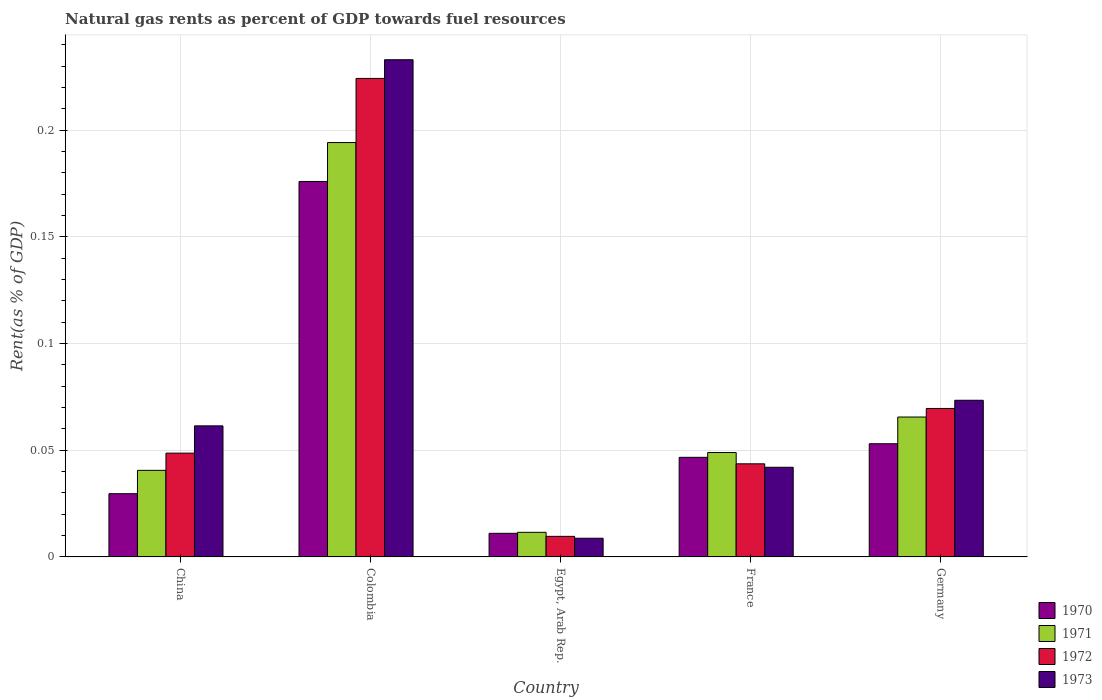How many different coloured bars are there?
Your response must be concise. 4. Are the number of bars per tick equal to the number of legend labels?
Keep it short and to the point. Yes. How many bars are there on the 5th tick from the left?
Your answer should be compact. 4. How many bars are there on the 4th tick from the right?
Provide a short and direct response. 4. What is the label of the 5th group of bars from the left?
Offer a terse response. Germany. In how many cases, is the number of bars for a given country not equal to the number of legend labels?
Offer a terse response. 0. What is the matural gas rent in 1972 in China?
Offer a terse response. 0.05. Across all countries, what is the maximum matural gas rent in 1972?
Give a very brief answer. 0.22. Across all countries, what is the minimum matural gas rent in 1970?
Give a very brief answer. 0.01. In which country was the matural gas rent in 1971 minimum?
Keep it short and to the point. Egypt, Arab Rep. What is the total matural gas rent in 1971 in the graph?
Make the answer very short. 0.36. What is the difference between the matural gas rent in 1972 in China and that in France?
Offer a very short reply. 0.01. What is the difference between the matural gas rent in 1970 in Germany and the matural gas rent in 1971 in Egypt, Arab Rep.?
Your answer should be very brief. 0.04. What is the average matural gas rent in 1972 per country?
Your answer should be compact. 0.08. What is the difference between the matural gas rent of/in 1972 and matural gas rent of/in 1971 in France?
Offer a terse response. -0.01. What is the ratio of the matural gas rent in 1970 in China to that in Egypt, Arab Rep.?
Ensure brevity in your answer.  2.68. Is the matural gas rent in 1972 in Colombia less than that in France?
Your answer should be compact. No. What is the difference between the highest and the second highest matural gas rent in 1971?
Provide a succinct answer. 0.13. What is the difference between the highest and the lowest matural gas rent in 1973?
Offer a terse response. 0.22. Is the sum of the matural gas rent in 1973 in Colombia and Egypt, Arab Rep. greater than the maximum matural gas rent in 1970 across all countries?
Your response must be concise. Yes. Is it the case that in every country, the sum of the matural gas rent in 1971 and matural gas rent in 1973 is greater than the sum of matural gas rent in 1970 and matural gas rent in 1972?
Your answer should be compact. No. What does the 2nd bar from the left in China represents?
Offer a terse response. 1971. What does the 2nd bar from the right in Egypt, Arab Rep. represents?
Make the answer very short. 1972. Is it the case that in every country, the sum of the matural gas rent in 1973 and matural gas rent in 1970 is greater than the matural gas rent in 1972?
Make the answer very short. Yes. How many bars are there?
Your answer should be compact. 20. Are all the bars in the graph horizontal?
Keep it short and to the point. No. How many countries are there in the graph?
Offer a terse response. 5. Does the graph contain any zero values?
Provide a short and direct response. No. Does the graph contain grids?
Offer a terse response. Yes. What is the title of the graph?
Keep it short and to the point. Natural gas rents as percent of GDP towards fuel resources. Does "1981" appear as one of the legend labels in the graph?
Your answer should be very brief. No. What is the label or title of the X-axis?
Offer a very short reply. Country. What is the label or title of the Y-axis?
Your answer should be very brief. Rent(as % of GDP). What is the Rent(as % of GDP) of 1970 in China?
Offer a very short reply. 0.03. What is the Rent(as % of GDP) of 1971 in China?
Provide a succinct answer. 0.04. What is the Rent(as % of GDP) of 1972 in China?
Provide a succinct answer. 0.05. What is the Rent(as % of GDP) of 1973 in China?
Your answer should be compact. 0.06. What is the Rent(as % of GDP) of 1970 in Colombia?
Keep it short and to the point. 0.18. What is the Rent(as % of GDP) of 1971 in Colombia?
Make the answer very short. 0.19. What is the Rent(as % of GDP) of 1972 in Colombia?
Your response must be concise. 0.22. What is the Rent(as % of GDP) of 1973 in Colombia?
Ensure brevity in your answer.  0.23. What is the Rent(as % of GDP) of 1970 in Egypt, Arab Rep.?
Provide a short and direct response. 0.01. What is the Rent(as % of GDP) of 1971 in Egypt, Arab Rep.?
Your answer should be very brief. 0.01. What is the Rent(as % of GDP) of 1972 in Egypt, Arab Rep.?
Provide a succinct answer. 0.01. What is the Rent(as % of GDP) in 1973 in Egypt, Arab Rep.?
Ensure brevity in your answer.  0.01. What is the Rent(as % of GDP) of 1970 in France?
Make the answer very short. 0.05. What is the Rent(as % of GDP) in 1971 in France?
Your answer should be compact. 0.05. What is the Rent(as % of GDP) of 1972 in France?
Keep it short and to the point. 0.04. What is the Rent(as % of GDP) in 1973 in France?
Keep it short and to the point. 0.04. What is the Rent(as % of GDP) of 1970 in Germany?
Provide a succinct answer. 0.05. What is the Rent(as % of GDP) in 1971 in Germany?
Your answer should be very brief. 0.07. What is the Rent(as % of GDP) of 1972 in Germany?
Offer a terse response. 0.07. What is the Rent(as % of GDP) in 1973 in Germany?
Provide a short and direct response. 0.07. Across all countries, what is the maximum Rent(as % of GDP) in 1970?
Offer a very short reply. 0.18. Across all countries, what is the maximum Rent(as % of GDP) of 1971?
Keep it short and to the point. 0.19. Across all countries, what is the maximum Rent(as % of GDP) of 1972?
Your answer should be compact. 0.22. Across all countries, what is the maximum Rent(as % of GDP) of 1973?
Ensure brevity in your answer.  0.23. Across all countries, what is the minimum Rent(as % of GDP) in 1970?
Provide a succinct answer. 0.01. Across all countries, what is the minimum Rent(as % of GDP) in 1971?
Provide a short and direct response. 0.01. Across all countries, what is the minimum Rent(as % of GDP) of 1972?
Offer a terse response. 0.01. Across all countries, what is the minimum Rent(as % of GDP) in 1973?
Your answer should be very brief. 0.01. What is the total Rent(as % of GDP) in 1970 in the graph?
Ensure brevity in your answer.  0.32. What is the total Rent(as % of GDP) of 1971 in the graph?
Keep it short and to the point. 0.36. What is the total Rent(as % of GDP) in 1972 in the graph?
Make the answer very short. 0.4. What is the total Rent(as % of GDP) in 1973 in the graph?
Your response must be concise. 0.42. What is the difference between the Rent(as % of GDP) in 1970 in China and that in Colombia?
Keep it short and to the point. -0.15. What is the difference between the Rent(as % of GDP) in 1971 in China and that in Colombia?
Your answer should be compact. -0.15. What is the difference between the Rent(as % of GDP) in 1972 in China and that in Colombia?
Your answer should be very brief. -0.18. What is the difference between the Rent(as % of GDP) in 1973 in China and that in Colombia?
Give a very brief answer. -0.17. What is the difference between the Rent(as % of GDP) in 1970 in China and that in Egypt, Arab Rep.?
Your response must be concise. 0.02. What is the difference between the Rent(as % of GDP) in 1971 in China and that in Egypt, Arab Rep.?
Ensure brevity in your answer.  0.03. What is the difference between the Rent(as % of GDP) in 1972 in China and that in Egypt, Arab Rep.?
Your response must be concise. 0.04. What is the difference between the Rent(as % of GDP) in 1973 in China and that in Egypt, Arab Rep.?
Provide a succinct answer. 0.05. What is the difference between the Rent(as % of GDP) in 1970 in China and that in France?
Ensure brevity in your answer.  -0.02. What is the difference between the Rent(as % of GDP) of 1971 in China and that in France?
Offer a terse response. -0.01. What is the difference between the Rent(as % of GDP) in 1972 in China and that in France?
Ensure brevity in your answer.  0.01. What is the difference between the Rent(as % of GDP) in 1973 in China and that in France?
Offer a terse response. 0.02. What is the difference between the Rent(as % of GDP) of 1970 in China and that in Germany?
Make the answer very short. -0.02. What is the difference between the Rent(as % of GDP) of 1971 in China and that in Germany?
Provide a short and direct response. -0.03. What is the difference between the Rent(as % of GDP) in 1972 in China and that in Germany?
Make the answer very short. -0.02. What is the difference between the Rent(as % of GDP) of 1973 in China and that in Germany?
Offer a very short reply. -0.01. What is the difference between the Rent(as % of GDP) in 1970 in Colombia and that in Egypt, Arab Rep.?
Ensure brevity in your answer.  0.16. What is the difference between the Rent(as % of GDP) in 1971 in Colombia and that in Egypt, Arab Rep.?
Provide a succinct answer. 0.18. What is the difference between the Rent(as % of GDP) of 1972 in Colombia and that in Egypt, Arab Rep.?
Ensure brevity in your answer.  0.21. What is the difference between the Rent(as % of GDP) of 1973 in Colombia and that in Egypt, Arab Rep.?
Keep it short and to the point. 0.22. What is the difference between the Rent(as % of GDP) in 1970 in Colombia and that in France?
Your response must be concise. 0.13. What is the difference between the Rent(as % of GDP) in 1971 in Colombia and that in France?
Provide a short and direct response. 0.15. What is the difference between the Rent(as % of GDP) in 1972 in Colombia and that in France?
Your response must be concise. 0.18. What is the difference between the Rent(as % of GDP) of 1973 in Colombia and that in France?
Provide a short and direct response. 0.19. What is the difference between the Rent(as % of GDP) of 1970 in Colombia and that in Germany?
Make the answer very short. 0.12. What is the difference between the Rent(as % of GDP) in 1971 in Colombia and that in Germany?
Make the answer very short. 0.13. What is the difference between the Rent(as % of GDP) of 1972 in Colombia and that in Germany?
Offer a very short reply. 0.15. What is the difference between the Rent(as % of GDP) in 1973 in Colombia and that in Germany?
Ensure brevity in your answer.  0.16. What is the difference between the Rent(as % of GDP) of 1970 in Egypt, Arab Rep. and that in France?
Provide a short and direct response. -0.04. What is the difference between the Rent(as % of GDP) in 1971 in Egypt, Arab Rep. and that in France?
Your answer should be compact. -0.04. What is the difference between the Rent(as % of GDP) in 1972 in Egypt, Arab Rep. and that in France?
Your response must be concise. -0.03. What is the difference between the Rent(as % of GDP) of 1973 in Egypt, Arab Rep. and that in France?
Your answer should be compact. -0.03. What is the difference between the Rent(as % of GDP) of 1970 in Egypt, Arab Rep. and that in Germany?
Provide a succinct answer. -0.04. What is the difference between the Rent(as % of GDP) of 1971 in Egypt, Arab Rep. and that in Germany?
Offer a terse response. -0.05. What is the difference between the Rent(as % of GDP) in 1972 in Egypt, Arab Rep. and that in Germany?
Ensure brevity in your answer.  -0.06. What is the difference between the Rent(as % of GDP) in 1973 in Egypt, Arab Rep. and that in Germany?
Provide a succinct answer. -0.06. What is the difference between the Rent(as % of GDP) of 1970 in France and that in Germany?
Offer a terse response. -0.01. What is the difference between the Rent(as % of GDP) in 1971 in France and that in Germany?
Provide a succinct answer. -0.02. What is the difference between the Rent(as % of GDP) of 1972 in France and that in Germany?
Your answer should be compact. -0.03. What is the difference between the Rent(as % of GDP) in 1973 in France and that in Germany?
Provide a succinct answer. -0.03. What is the difference between the Rent(as % of GDP) in 1970 in China and the Rent(as % of GDP) in 1971 in Colombia?
Your answer should be compact. -0.16. What is the difference between the Rent(as % of GDP) of 1970 in China and the Rent(as % of GDP) of 1972 in Colombia?
Your answer should be compact. -0.19. What is the difference between the Rent(as % of GDP) of 1970 in China and the Rent(as % of GDP) of 1973 in Colombia?
Your answer should be very brief. -0.2. What is the difference between the Rent(as % of GDP) of 1971 in China and the Rent(as % of GDP) of 1972 in Colombia?
Ensure brevity in your answer.  -0.18. What is the difference between the Rent(as % of GDP) of 1971 in China and the Rent(as % of GDP) of 1973 in Colombia?
Keep it short and to the point. -0.19. What is the difference between the Rent(as % of GDP) of 1972 in China and the Rent(as % of GDP) of 1973 in Colombia?
Ensure brevity in your answer.  -0.18. What is the difference between the Rent(as % of GDP) in 1970 in China and the Rent(as % of GDP) in 1971 in Egypt, Arab Rep.?
Your answer should be very brief. 0.02. What is the difference between the Rent(as % of GDP) in 1970 in China and the Rent(as % of GDP) in 1973 in Egypt, Arab Rep.?
Make the answer very short. 0.02. What is the difference between the Rent(as % of GDP) of 1971 in China and the Rent(as % of GDP) of 1972 in Egypt, Arab Rep.?
Offer a very short reply. 0.03. What is the difference between the Rent(as % of GDP) in 1971 in China and the Rent(as % of GDP) in 1973 in Egypt, Arab Rep.?
Provide a succinct answer. 0.03. What is the difference between the Rent(as % of GDP) in 1972 in China and the Rent(as % of GDP) in 1973 in Egypt, Arab Rep.?
Ensure brevity in your answer.  0.04. What is the difference between the Rent(as % of GDP) in 1970 in China and the Rent(as % of GDP) in 1971 in France?
Your answer should be very brief. -0.02. What is the difference between the Rent(as % of GDP) in 1970 in China and the Rent(as % of GDP) in 1972 in France?
Offer a very short reply. -0.01. What is the difference between the Rent(as % of GDP) of 1970 in China and the Rent(as % of GDP) of 1973 in France?
Your answer should be very brief. -0.01. What is the difference between the Rent(as % of GDP) of 1971 in China and the Rent(as % of GDP) of 1972 in France?
Your answer should be very brief. -0. What is the difference between the Rent(as % of GDP) of 1971 in China and the Rent(as % of GDP) of 1973 in France?
Provide a succinct answer. -0. What is the difference between the Rent(as % of GDP) of 1972 in China and the Rent(as % of GDP) of 1973 in France?
Provide a succinct answer. 0.01. What is the difference between the Rent(as % of GDP) of 1970 in China and the Rent(as % of GDP) of 1971 in Germany?
Provide a succinct answer. -0.04. What is the difference between the Rent(as % of GDP) in 1970 in China and the Rent(as % of GDP) in 1972 in Germany?
Make the answer very short. -0.04. What is the difference between the Rent(as % of GDP) of 1970 in China and the Rent(as % of GDP) of 1973 in Germany?
Your response must be concise. -0.04. What is the difference between the Rent(as % of GDP) in 1971 in China and the Rent(as % of GDP) in 1972 in Germany?
Your answer should be very brief. -0.03. What is the difference between the Rent(as % of GDP) in 1971 in China and the Rent(as % of GDP) in 1973 in Germany?
Make the answer very short. -0.03. What is the difference between the Rent(as % of GDP) in 1972 in China and the Rent(as % of GDP) in 1973 in Germany?
Make the answer very short. -0.02. What is the difference between the Rent(as % of GDP) of 1970 in Colombia and the Rent(as % of GDP) of 1971 in Egypt, Arab Rep.?
Provide a short and direct response. 0.16. What is the difference between the Rent(as % of GDP) in 1970 in Colombia and the Rent(as % of GDP) in 1972 in Egypt, Arab Rep.?
Your answer should be very brief. 0.17. What is the difference between the Rent(as % of GDP) in 1970 in Colombia and the Rent(as % of GDP) in 1973 in Egypt, Arab Rep.?
Provide a succinct answer. 0.17. What is the difference between the Rent(as % of GDP) in 1971 in Colombia and the Rent(as % of GDP) in 1972 in Egypt, Arab Rep.?
Provide a short and direct response. 0.18. What is the difference between the Rent(as % of GDP) of 1971 in Colombia and the Rent(as % of GDP) of 1973 in Egypt, Arab Rep.?
Your answer should be very brief. 0.19. What is the difference between the Rent(as % of GDP) in 1972 in Colombia and the Rent(as % of GDP) in 1973 in Egypt, Arab Rep.?
Your answer should be compact. 0.22. What is the difference between the Rent(as % of GDP) in 1970 in Colombia and the Rent(as % of GDP) in 1971 in France?
Your response must be concise. 0.13. What is the difference between the Rent(as % of GDP) of 1970 in Colombia and the Rent(as % of GDP) of 1972 in France?
Offer a very short reply. 0.13. What is the difference between the Rent(as % of GDP) of 1970 in Colombia and the Rent(as % of GDP) of 1973 in France?
Offer a terse response. 0.13. What is the difference between the Rent(as % of GDP) in 1971 in Colombia and the Rent(as % of GDP) in 1972 in France?
Your answer should be very brief. 0.15. What is the difference between the Rent(as % of GDP) of 1971 in Colombia and the Rent(as % of GDP) of 1973 in France?
Your answer should be very brief. 0.15. What is the difference between the Rent(as % of GDP) in 1972 in Colombia and the Rent(as % of GDP) in 1973 in France?
Your answer should be compact. 0.18. What is the difference between the Rent(as % of GDP) in 1970 in Colombia and the Rent(as % of GDP) in 1971 in Germany?
Provide a succinct answer. 0.11. What is the difference between the Rent(as % of GDP) in 1970 in Colombia and the Rent(as % of GDP) in 1972 in Germany?
Offer a very short reply. 0.11. What is the difference between the Rent(as % of GDP) of 1970 in Colombia and the Rent(as % of GDP) of 1973 in Germany?
Provide a short and direct response. 0.1. What is the difference between the Rent(as % of GDP) of 1971 in Colombia and the Rent(as % of GDP) of 1972 in Germany?
Your response must be concise. 0.12. What is the difference between the Rent(as % of GDP) of 1971 in Colombia and the Rent(as % of GDP) of 1973 in Germany?
Your response must be concise. 0.12. What is the difference between the Rent(as % of GDP) of 1972 in Colombia and the Rent(as % of GDP) of 1973 in Germany?
Offer a very short reply. 0.15. What is the difference between the Rent(as % of GDP) in 1970 in Egypt, Arab Rep. and the Rent(as % of GDP) in 1971 in France?
Ensure brevity in your answer.  -0.04. What is the difference between the Rent(as % of GDP) of 1970 in Egypt, Arab Rep. and the Rent(as % of GDP) of 1972 in France?
Give a very brief answer. -0.03. What is the difference between the Rent(as % of GDP) of 1970 in Egypt, Arab Rep. and the Rent(as % of GDP) of 1973 in France?
Your response must be concise. -0.03. What is the difference between the Rent(as % of GDP) of 1971 in Egypt, Arab Rep. and the Rent(as % of GDP) of 1972 in France?
Ensure brevity in your answer.  -0.03. What is the difference between the Rent(as % of GDP) of 1971 in Egypt, Arab Rep. and the Rent(as % of GDP) of 1973 in France?
Give a very brief answer. -0.03. What is the difference between the Rent(as % of GDP) of 1972 in Egypt, Arab Rep. and the Rent(as % of GDP) of 1973 in France?
Make the answer very short. -0.03. What is the difference between the Rent(as % of GDP) in 1970 in Egypt, Arab Rep. and the Rent(as % of GDP) in 1971 in Germany?
Offer a terse response. -0.05. What is the difference between the Rent(as % of GDP) in 1970 in Egypt, Arab Rep. and the Rent(as % of GDP) in 1972 in Germany?
Offer a very short reply. -0.06. What is the difference between the Rent(as % of GDP) of 1970 in Egypt, Arab Rep. and the Rent(as % of GDP) of 1973 in Germany?
Provide a succinct answer. -0.06. What is the difference between the Rent(as % of GDP) in 1971 in Egypt, Arab Rep. and the Rent(as % of GDP) in 1972 in Germany?
Give a very brief answer. -0.06. What is the difference between the Rent(as % of GDP) of 1971 in Egypt, Arab Rep. and the Rent(as % of GDP) of 1973 in Germany?
Give a very brief answer. -0.06. What is the difference between the Rent(as % of GDP) in 1972 in Egypt, Arab Rep. and the Rent(as % of GDP) in 1973 in Germany?
Give a very brief answer. -0.06. What is the difference between the Rent(as % of GDP) in 1970 in France and the Rent(as % of GDP) in 1971 in Germany?
Your answer should be very brief. -0.02. What is the difference between the Rent(as % of GDP) in 1970 in France and the Rent(as % of GDP) in 1972 in Germany?
Offer a terse response. -0.02. What is the difference between the Rent(as % of GDP) of 1970 in France and the Rent(as % of GDP) of 1973 in Germany?
Provide a succinct answer. -0.03. What is the difference between the Rent(as % of GDP) of 1971 in France and the Rent(as % of GDP) of 1972 in Germany?
Your response must be concise. -0.02. What is the difference between the Rent(as % of GDP) in 1971 in France and the Rent(as % of GDP) in 1973 in Germany?
Your response must be concise. -0.02. What is the difference between the Rent(as % of GDP) in 1972 in France and the Rent(as % of GDP) in 1973 in Germany?
Ensure brevity in your answer.  -0.03. What is the average Rent(as % of GDP) in 1970 per country?
Give a very brief answer. 0.06. What is the average Rent(as % of GDP) in 1971 per country?
Give a very brief answer. 0.07. What is the average Rent(as % of GDP) of 1972 per country?
Your response must be concise. 0.08. What is the average Rent(as % of GDP) in 1973 per country?
Provide a short and direct response. 0.08. What is the difference between the Rent(as % of GDP) of 1970 and Rent(as % of GDP) of 1971 in China?
Keep it short and to the point. -0.01. What is the difference between the Rent(as % of GDP) in 1970 and Rent(as % of GDP) in 1972 in China?
Your response must be concise. -0.02. What is the difference between the Rent(as % of GDP) in 1970 and Rent(as % of GDP) in 1973 in China?
Offer a terse response. -0.03. What is the difference between the Rent(as % of GDP) in 1971 and Rent(as % of GDP) in 1972 in China?
Your answer should be very brief. -0.01. What is the difference between the Rent(as % of GDP) of 1971 and Rent(as % of GDP) of 1973 in China?
Keep it short and to the point. -0.02. What is the difference between the Rent(as % of GDP) of 1972 and Rent(as % of GDP) of 1973 in China?
Your answer should be compact. -0.01. What is the difference between the Rent(as % of GDP) in 1970 and Rent(as % of GDP) in 1971 in Colombia?
Offer a terse response. -0.02. What is the difference between the Rent(as % of GDP) in 1970 and Rent(as % of GDP) in 1972 in Colombia?
Make the answer very short. -0.05. What is the difference between the Rent(as % of GDP) in 1970 and Rent(as % of GDP) in 1973 in Colombia?
Offer a very short reply. -0.06. What is the difference between the Rent(as % of GDP) of 1971 and Rent(as % of GDP) of 1972 in Colombia?
Your answer should be very brief. -0.03. What is the difference between the Rent(as % of GDP) in 1971 and Rent(as % of GDP) in 1973 in Colombia?
Ensure brevity in your answer.  -0.04. What is the difference between the Rent(as % of GDP) in 1972 and Rent(as % of GDP) in 1973 in Colombia?
Give a very brief answer. -0.01. What is the difference between the Rent(as % of GDP) of 1970 and Rent(as % of GDP) of 1971 in Egypt, Arab Rep.?
Provide a succinct answer. -0. What is the difference between the Rent(as % of GDP) of 1970 and Rent(as % of GDP) of 1972 in Egypt, Arab Rep.?
Give a very brief answer. 0. What is the difference between the Rent(as % of GDP) in 1970 and Rent(as % of GDP) in 1973 in Egypt, Arab Rep.?
Keep it short and to the point. 0. What is the difference between the Rent(as % of GDP) of 1971 and Rent(as % of GDP) of 1972 in Egypt, Arab Rep.?
Provide a succinct answer. 0. What is the difference between the Rent(as % of GDP) in 1971 and Rent(as % of GDP) in 1973 in Egypt, Arab Rep.?
Provide a short and direct response. 0. What is the difference between the Rent(as % of GDP) in 1972 and Rent(as % of GDP) in 1973 in Egypt, Arab Rep.?
Your answer should be compact. 0. What is the difference between the Rent(as % of GDP) in 1970 and Rent(as % of GDP) in 1971 in France?
Your answer should be very brief. -0. What is the difference between the Rent(as % of GDP) in 1970 and Rent(as % of GDP) in 1972 in France?
Make the answer very short. 0. What is the difference between the Rent(as % of GDP) in 1970 and Rent(as % of GDP) in 1973 in France?
Your response must be concise. 0. What is the difference between the Rent(as % of GDP) of 1971 and Rent(as % of GDP) of 1972 in France?
Keep it short and to the point. 0.01. What is the difference between the Rent(as % of GDP) in 1971 and Rent(as % of GDP) in 1973 in France?
Make the answer very short. 0.01. What is the difference between the Rent(as % of GDP) in 1972 and Rent(as % of GDP) in 1973 in France?
Give a very brief answer. 0. What is the difference between the Rent(as % of GDP) in 1970 and Rent(as % of GDP) in 1971 in Germany?
Your answer should be compact. -0.01. What is the difference between the Rent(as % of GDP) in 1970 and Rent(as % of GDP) in 1972 in Germany?
Your answer should be very brief. -0.02. What is the difference between the Rent(as % of GDP) in 1970 and Rent(as % of GDP) in 1973 in Germany?
Your response must be concise. -0.02. What is the difference between the Rent(as % of GDP) in 1971 and Rent(as % of GDP) in 1972 in Germany?
Offer a very short reply. -0. What is the difference between the Rent(as % of GDP) in 1971 and Rent(as % of GDP) in 1973 in Germany?
Offer a very short reply. -0.01. What is the difference between the Rent(as % of GDP) of 1972 and Rent(as % of GDP) of 1973 in Germany?
Your answer should be very brief. -0. What is the ratio of the Rent(as % of GDP) in 1970 in China to that in Colombia?
Your response must be concise. 0.17. What is the ratio of the Rent(as % of GDP) in 1971 in China to that in Colombia?
Offer a very short reply. 0.21. What is the ratio of the Rent(as % of GDP) in 1972 in China to that in Colombia?
Ensure brevity in your answer.  0.22. What is the ratio of the Rent(as % of GDP) of 1973 in China to that in Colombia?
Your response must be concise. 0.26. What is the ratio of the Rent(as % of GDP) in 1970 in China to that in Egypt, Arab Rep.?
Offer a terse response. 2.68. What is the ratio of the Rent(as % of GDP) in 1971 in China to that in Egypt, Arab Rep.?
Your answer should be very brief. 3.52. What is the ratio of the Rent(as % of GDP) in 1972 in China to that in Egypt, Arab Rep.?
Offer a terse response. 5.04. What is the ratio of the Rent(as % of GDP) in 1973 in China to that in Egypt, Arab Rep.?
Provide a succinct answer. 7.01. What is the ratio of the Rent(as % of GDP) in 1970 in China to that in France?
Your answer should be very brief. 0.64. What is the ratio of the Rent(as % of GDP) of 1971 in China to that in France?
Your response must be concise. 0.83. What is the ratio of the Rent(as % of GDP) in 1972 in China to that in France?
Your response must be concise. 1.11. What is the ratio of the Rent(as % of GDP) in 1973 in China to that in France?
Make the answer very short. 1.46. What is the ratio of the Rent(as % of GDP) in 1970 in China to that in Germany?
Ensure brevity in your answer.  0.56. What is the ratio of the Rent(as % of GDP) in 1971 in China to that in Germany?
Provide a succinct answer. 0.62. What is the ratio of the Rent(as % of GDP) of 1972 in China to that in Germany?
Offer a very short reply. 0.7. What is the ratio of the Rent(as % of GDP) in 1973 in China to that in Germany?
Your answer should be very brief. 0.84. What is the ratio of the Rent(as % of GDP) in 1970 in Colombia to that in Egypt, Arab Rep.?
Give a very brief answer. 15.9. What is the ratio of the Rent(as % of GDP) in 1971 in Colombia to that in Egypt, Arab Rep.?
Give a very brief answer. 16.84. What is the ratio of the Rent(as % of GDP) of 1972 in Colombia to that in Egypt, Arab Rep.?
Your response must be concise. 23.25. What is the ratio of the Rent(as % of GDP) in 1973 in Colombia to that in Egypt, Arab Rep.?
Give a very brief answer. 26.6. What is the ratio of the Rent(as % of GDP) in 1970 in Colombia to that in France?
Give a very brief answer. 3.77. What is the ratio of the Rent(as % of GDP) in 1971 in Colombia to that in France?
Ensure brevity in your answer.  3.97. What is the ratio of the Rent(as % of GDP) of 1972 in Colombia to that in France?
Offer a very short reply. 5.14. What is the ratio of the Rent(as % of GDP) of 1973 in Colombia to that in France?
Make the answer very short. 5.55. What is the ratio of the Rent(as % of GDP) of 1970 in Colombia to that in Germany?
Make the answer very short. 3.32. What is the ratio of the Rent(as % of GDP) of 1971 in Colombia to that in Germany?
Provide a succinct answer. 2.96. What is the ratio of the Rent(as % of GDP) of 1972 in Colombia to that in Germany?
Make the answer very short. 3.22. What is the ratio of the Rent(as % of GDP) in 1973 in Colombia to that in Germany?
Your answer should be compact. 3.17. What is the ratio of the Rent(as % of GDP) of 1970 in Egypt, Arab Rep. to that in France?
Offer a terse response. 0.24. What is the ratio of the Rent(as % of GDP) in 1971 in Egypt, Arab Rep. to that in France?
Provide a short and direct response. 0.24. What is the ratio of the Rent(as % of GDP) of 1972 in Egypt, Arab Rep. to that in France?
Your answer should be compact. 0.22. What is the ratio of the Rent(as % of GDP) in 1973 in Egypt, Arab Rep. to that in France?
Give a very brief answer. 0.21. What is the ratio of the Rent(as % of GDP) in 1970 in Egypt, Arab Rep. to that in Germany?
Your answer should be compact. 0.21. What is the ratio of the Rent(as % of GDP) in 1971 in Egypt, Arab Rep. to that in Germany?
Ensure brevity in your answer.  0.18. What is the ratio of the Rent(as % of GDP) in 1972 in Egypt, Arab Rep. to that in Germany?
Ensure brevity in your answer.  0.14. What is the ratio of the Rent(as % of GDP) of 1973 in Egypt, Arab Rep. to that in Germany?
Offer a very short reply. 0.12. What is the ratio of the Rent(as % of GDP) of 1970 in France to that in Germany?
Your answer should be very brief. 0.88. What is the ratio of the Rent(as % of GDP) of 1971 in France to that in Germany?
Ensure brevity in your answer.  0.75. What is the ratio of the Rent(as % of GDP) of 1972 in France to that in Germany?
Offer a terse response. 0.63. What is the ratio of the Rent(as % of GDP) in 1973 in France to that in Germany?
Ensure brevity in your answer.  0.57. What is the difference between the highest and the second highest Rent(as % of GDP) of 1970?
Your response must be concise. 0.12. What is the difference between the highest and the second highest Rent(as % of GDP) of 1971?
Ensure brevity in your answer.  0.13. What is the difference between the highest and the second highest Rent(as % of GDP) of 1972?
Keep it short and to the point. 0.15. What is the difference between the highest and the second highest Rent(as % of GDP) in 1973?
Provide a succinct answer. 0.16. What is the difference between the highest and the lowest Rent(as % of GDP) of 1970?
Offer a very short reply. 0.16. What is the difference between the highest and the lowest Rent(as % of GDP) of 1971?
Provide a succinct answer. 0.18. What is the difference between the highest and the lowest Rent(as % of GDP) of 1972?
Provide a short and direct response. 0.21. What is the difference between the highest and the lowest Rent(as % of GDP) of 1973?
Offer a very short reply. 0.22. 